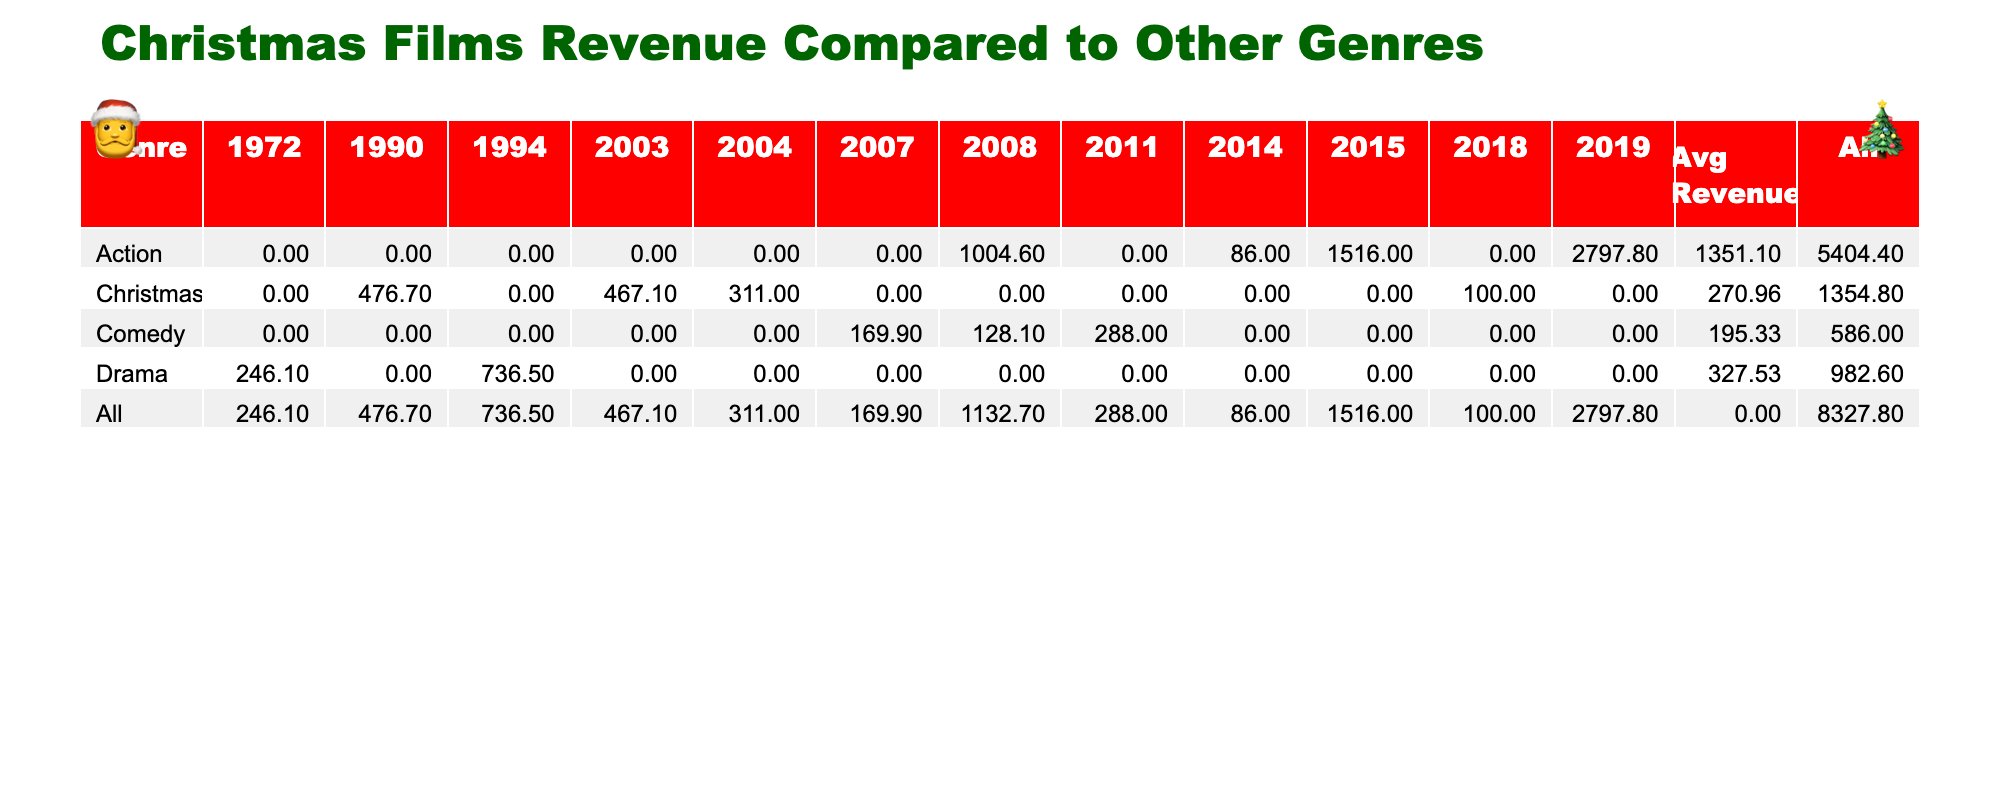What is the total revenue generated by Christmas films? The total revenue is obtained by summing the revenue values for all Christmas films listed. This includes Home Alone (476.7 million), The Christmas Chronicles (100.0 million), Elf (220.0 million), The Polar Express (311.0 million), and Love Actually (247.1 million). Adding these together gives 476.7 + 100 + 220 + 311 + 247.1 = 1354.8 million.
Answer: 1354.8 million What is the average revenue of Action films? To find the average revenue of Action films, we first sum the revenue of all Action films: Avengers: Endgame (2797.8 million), The Dark Knight (1004.6 million), John Wick (86.0 million), and Fast & Furious 7 (1516.0 million). The total revenue is 2797.8 + 1004.6 + 86 + 1516 = 4404.4 million. There are 4 Action films, so the average is 4404.4 / 4 = 1101.1 million.
Answer: 1101.1 million Which genre has the film with the highest revenue? By looking at the revenue values, Action films have the highest individual revenue with Avengers: Endgame at 2797.8 million. Comparing this to the highest revenue from Christmas films, which is Home Alone at 476.7 million, it's clear that Action has the highest revenue overall.
Answer: Action What is the difference in total revenue between Christmas films and Comedy films? First, calculate the total revenue of Christmas films (1354.8 million from previous calculations) and the total revenue of Comedy films: Superbad (169.9 million), Step Brothers (128.1 million), and Bridesmaids (288.0 million), which sums up to 169.9 + 128.1 + 288.0 = 586.0 million. Now, subtract the total revenue of Comedy from Christmas: 1354.8 - 586.0 = 768.8 million.
Answer: 768.8 million Is Love Actually the only Christmas film released in 2003? Reviewing the data, the films released in 2003 are Elf and Love Actually. Since Elf is also a Christmas film released in that year, Love Actually is not the only one.
Answer: No 